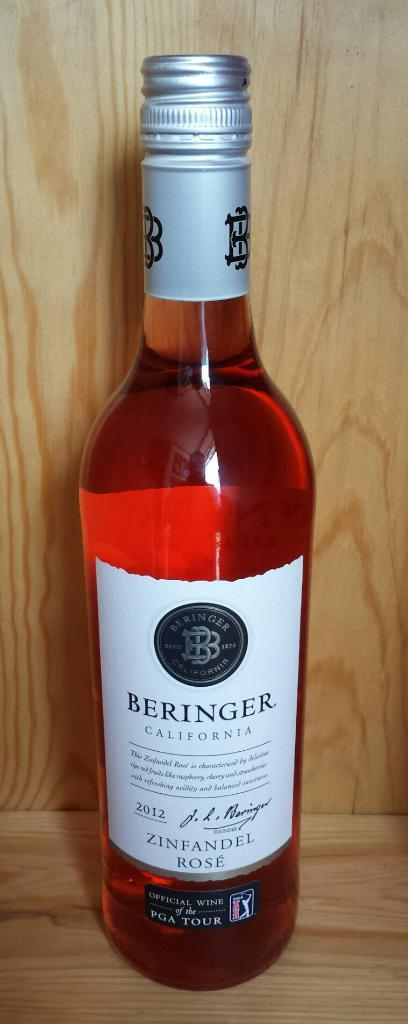<image>
Summarize the visual content of the image. A bottle of Beringer Rose was bottled in California. 